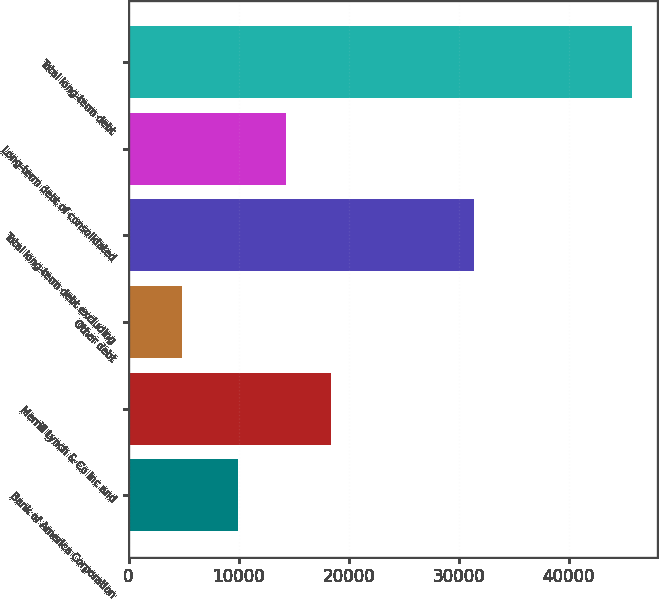<chart> <loc_0><loc_0><loc_500><loc_500><bar_chart><fcel>Bank of America Corporation<fcel>Merrill Lynch & Co Inc and<fcel>Other debt<fcel>Total long-term debt excluding<fcel>Long-term debt of consolidated<fcel>Total long-term debt<nl><fcel>9967<fcel>18442.9<fcel>4888<fcel>31434<fcel>14353<fcel>45787<nl></chart> 